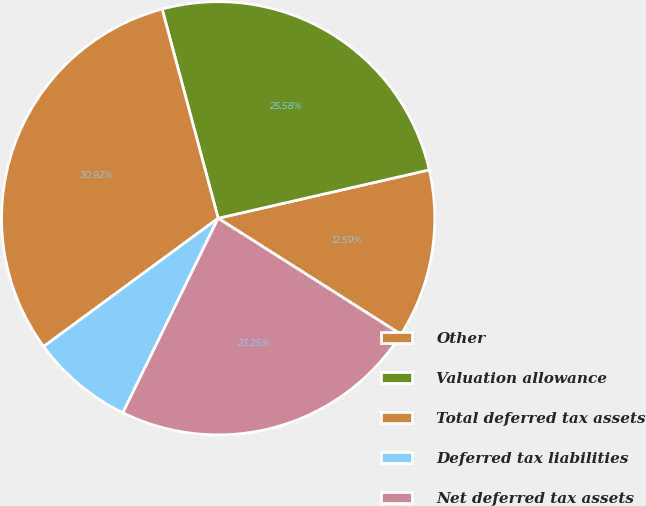<chart> <loc_0><loc_0><loc_500><loc_500><pie_chart><fcel>Other<fcel>Valuation allowance<fcel>Total deferred tax assets<fcel>Deferred tax liabilities<fcel>Net deferred tax assets<nl><fcel>12.59%<fcel>25.58%<fcel>30.92%<fcel>7.66%<fcel>23.25%<nl></chart> 